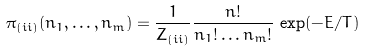Convert formula to latex. <formula><loc_0><loc_0><loc_500><loc_500>\pi _ { ( i i ) } ( n _ { 1 } , \dots , n _ { m } ) = \frac { 1 } { Z _ { ( i i ) } } \frac { n ! } { n _ { 1 } ! \dots n _ { m } ! } \, \exp ( - E / T )</formula> 